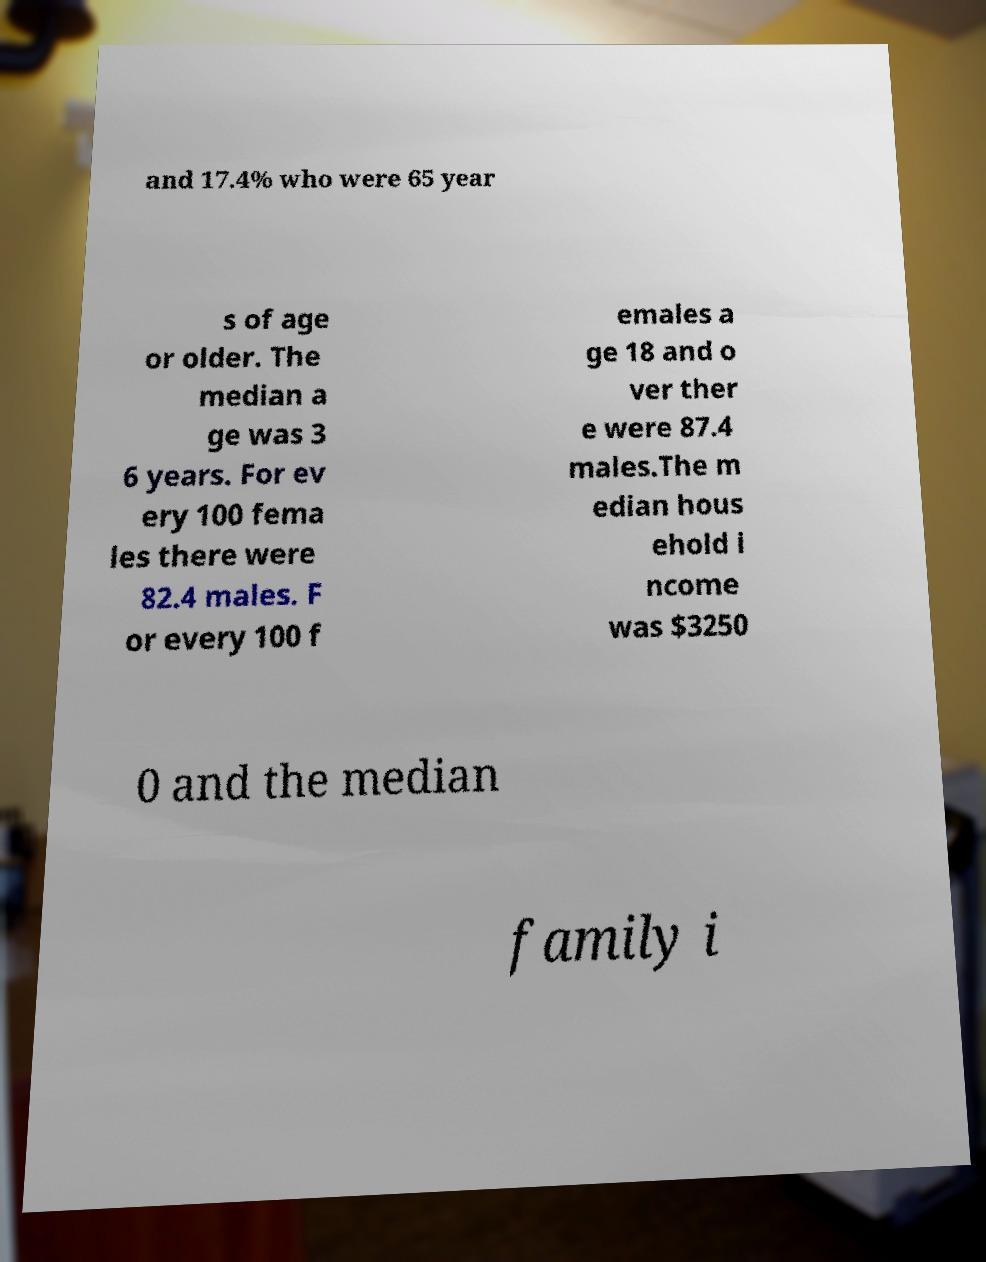For documentation purposes, I need the text within this image transcribed. Could you provide that? and 17.4% who were 65 year s of age or older. The median a ge was 3 6 years. For ev ery 100 fema les there were 82.4 males. F or every 100 f emales a ge 18 and o ver ther e were 87.4 males.The m edian hous ehold i ncome was $3250 0 and the median family i 